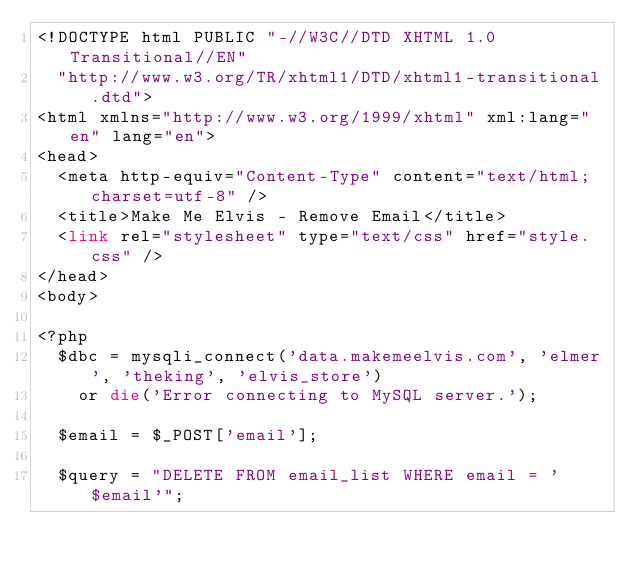<code> <loc_0><loc_0><loc_500><loc_500><_PHP_><!DOCTYPE html PUBLIC "-//W3C//DTD XHTML 1.0 Transitional//EN"
  "http://www.w3.org/TR/xhtml1/DTD/xhtml1-transitional.dtd">
<html xmlns="http://www.w3.org/1999/xhtml" xml:lang="en" lang="en">
<head>
  <meta http-equiv="Content-Type" content="text/html; charset=utf-8" />
  <title>Make Me Elvis - Remove Email</title>
  <link rel="stylesheet" type="text/css" href="style.css" />
</head>
<body>

<?php
  $dbc = mysqli_connect('data.makemeelvis.com', 'elmer', 'theking', 'elvis_store')
    or die('Error connecting to MySQL server.');

  $email = $_POST['email'];

  $query = "DELETE FROM email_list WHERE email = '$email'";</code> 